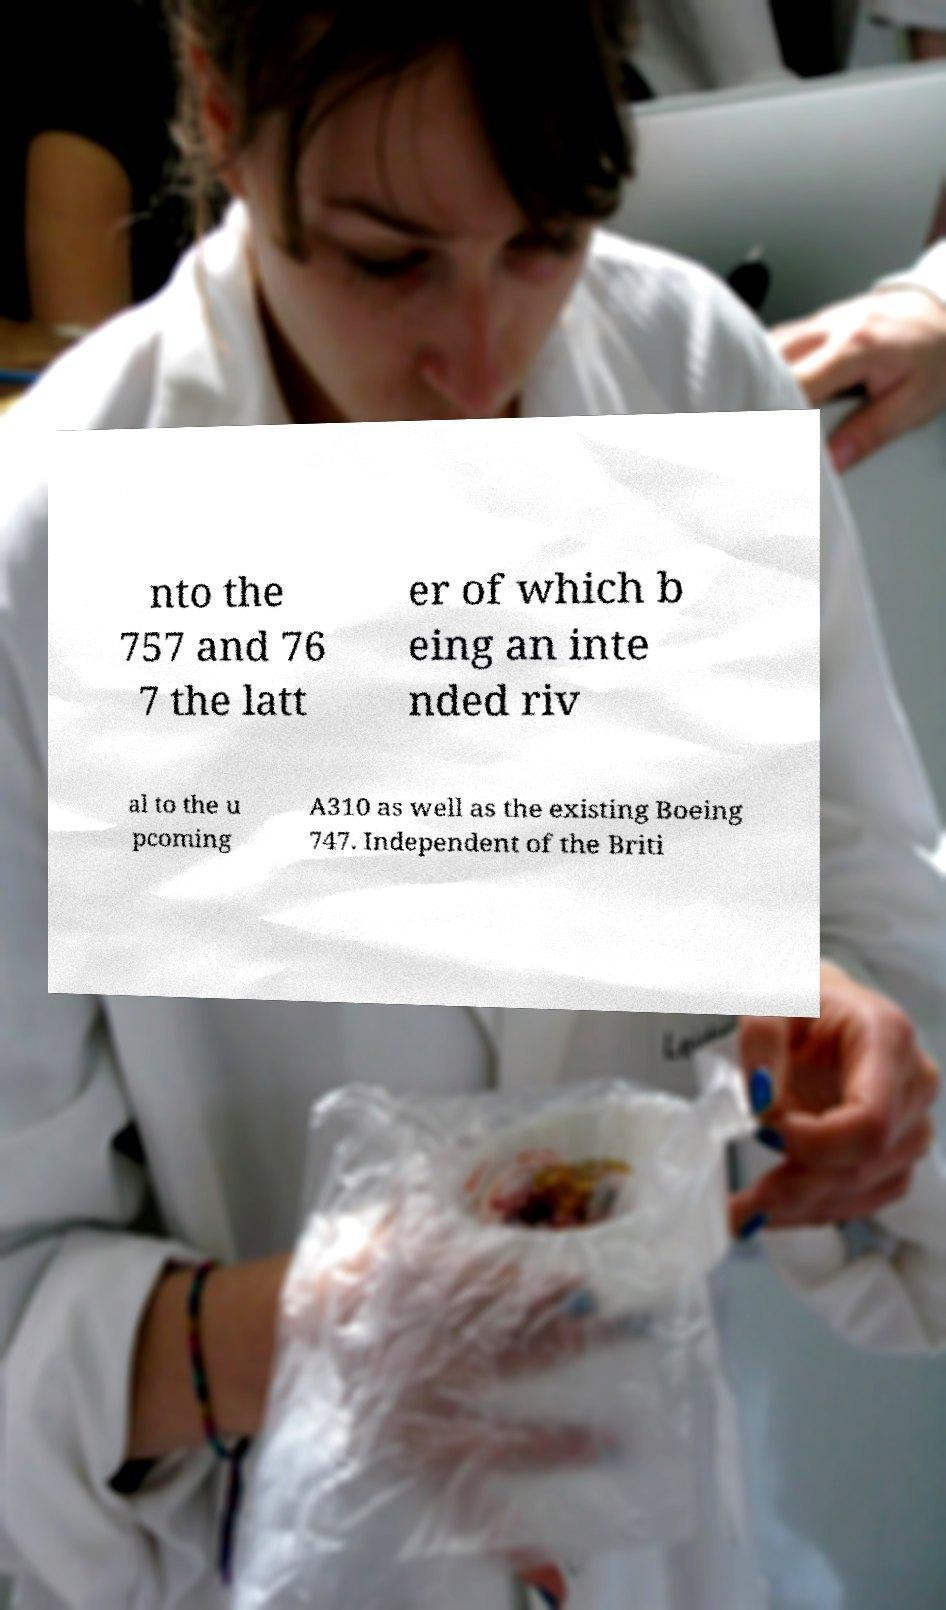Can you accurately transcribe the text from the provided image for me? nto the 757 and 76 7 the latt er of which b eing an inte nded riv al to the u pcoming A310 as well as the existing Boeing 747. Independent of the Briti 